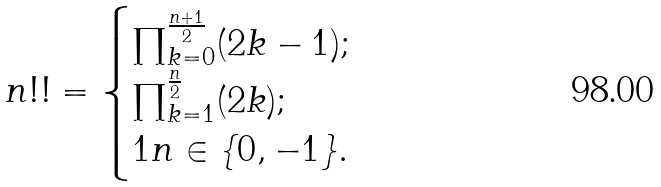<formula> <loc_0><loc_0><loc_500><loc_500>n ! ! = \begin{cases} \prod _ { k = 0 } ^ { \frac { n + 1 } { 2 } } ( 2 k - 1 ) ; \\ \prod _ { k = 1 } ^ { \frac { n } { 2 } } ( 2 k ) ; \\ 1 n \in \{ 0 , - 1 \} . \end{cases}</formula> 